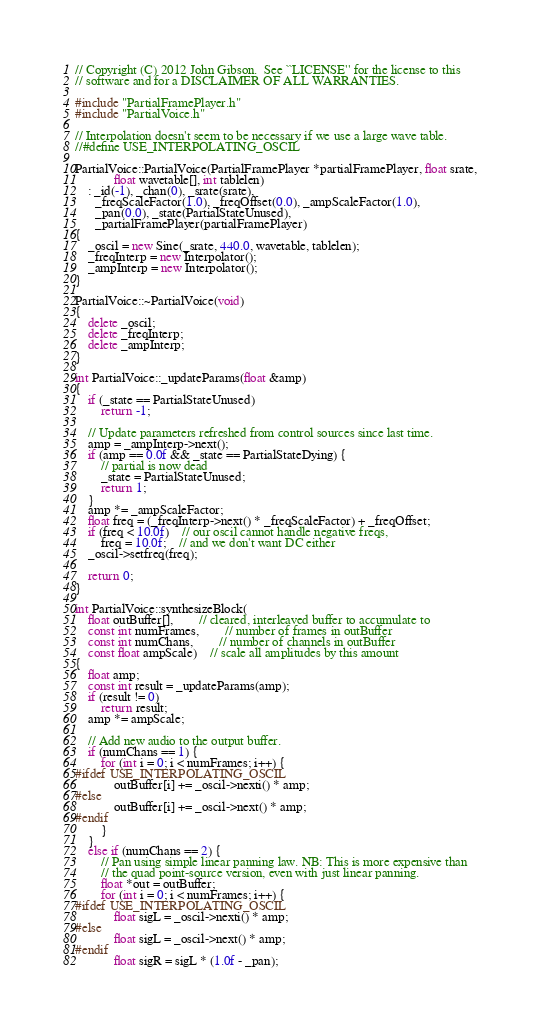<code> <loc_0><loc_0><loc_500><loc_500><_C++_>// Copyright (C) 2012 John Gibson.  See ``LICENSE'' for the license to this
// software and for a DISCLAIMER OF ALL WARRANTIES.

#include "PartialFramePlayer.h"
#include "PartialVoice.h"

// Interpolation doesn't seem to be necessary if we use a large wave table.
//#define USE_INTERPOLATING_OSCIL

PartialVoice::PartialVoice(PartialFramePlayer *partialFramePlayer, float srate,
			float wavetable[], int tablelen)
	: _id(-1), _chan(0), _srate(srate),
	  _freqScaleFactor(1.0), _freqOffset(0.0), _ampScaleFactor(1.0),
	  _pan(0.0), _state(PartialStateUnused),
	  _partialFramePlayer(partialFramePlayer)
{
	_oscil = new Sine(_srate, 440.0, wavetable, tablelen);
	_freqInterp = new Interpolator();
	_ampInterp = new Interpolator();
}

PartialVoice::~PartialVoice(void)
{
	delete _oscil;
	delete _freqInterp;
	delete _ampInterp;
}

int PartialVoice::_updateParams(float &amp)
{
	if (_state == PartialStateUnused)
		return -1;

	// Update parameters refreshed from control sources since last time.
	amp = _ampInterp->next();
	if (amp == 0.0f && _state == PartialStateDying) {
		// partial is now dead
		_state = PartialStateUnused;
		return 1;
	}
	amp *= _ampScaleFactor;
	float freq = (_freqInterp->next() * _freqScaleFactor) + _freqOffset;
	if (freq < 10.0f)	// our oscil cannot handle negative freqs,
		freq = 10.0f;	// and we don't want DC either
	_oscil->setfreq(freq);

	return 0;
}

int PartialVoice::synthesizeBlock(
	float outBuffer[],		// cleared, interleaved buffer to accumulate to
	const int numFrames,		// number of frames in outBuffer
	const int numChans,		// number of channels in outBuffer
	const float ampScale)	// scale all amplitudes by this amount
{
	float amp;
	const int result = _updateParams(amp);
	if (result != 0)
		return result;
	amp *= ampScale;

	// Add new audio to the output buffer.
	if (numChans == 1) {
		for (int i = 0; i < numFrames; i++) {
#ifdef USE_INTERPOLATING_OSCIL
			outBuffer[i] += _oscil->nexti() * amp;
#else
			outBuffer[i] += _oscil->next() * amp;
#endif
		}
	}
	else if (numChans == 2) {
		// Pan using simple linear panning law. NB: This is more expensive than
		// the quad point-source version, even with just linear panning.
		float *out = outBuffer;
		for (int i = 0; i < numFrames; i++) {
#ifdef USE_INTERPOLATING_OSCIL
			float sigL = _oscil->nexti() * amp;
#else
			float sigL = _oscil->next() * amp;
#endif
			float sigR = sigL * (1.0f - _pan);</code> 